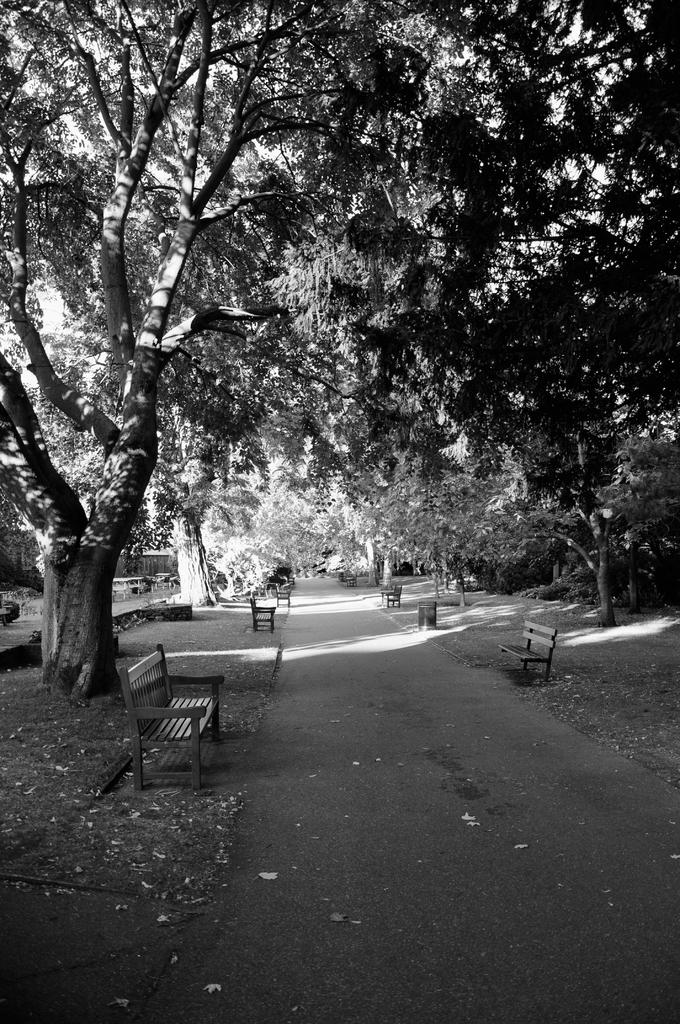What is the color scheme of the image? The image is black and white. What type of natural elements can be seen in the image? There are trees in the image. What type of man-made structures are present in the image? There are benches in the image. What is the main feature of the image's landscape? There is a road in the center of the image. What flavor of writing can be seen on the benches in the image? There is no writing present on the benches in the image, and therefore no flavor can be associated with it. 